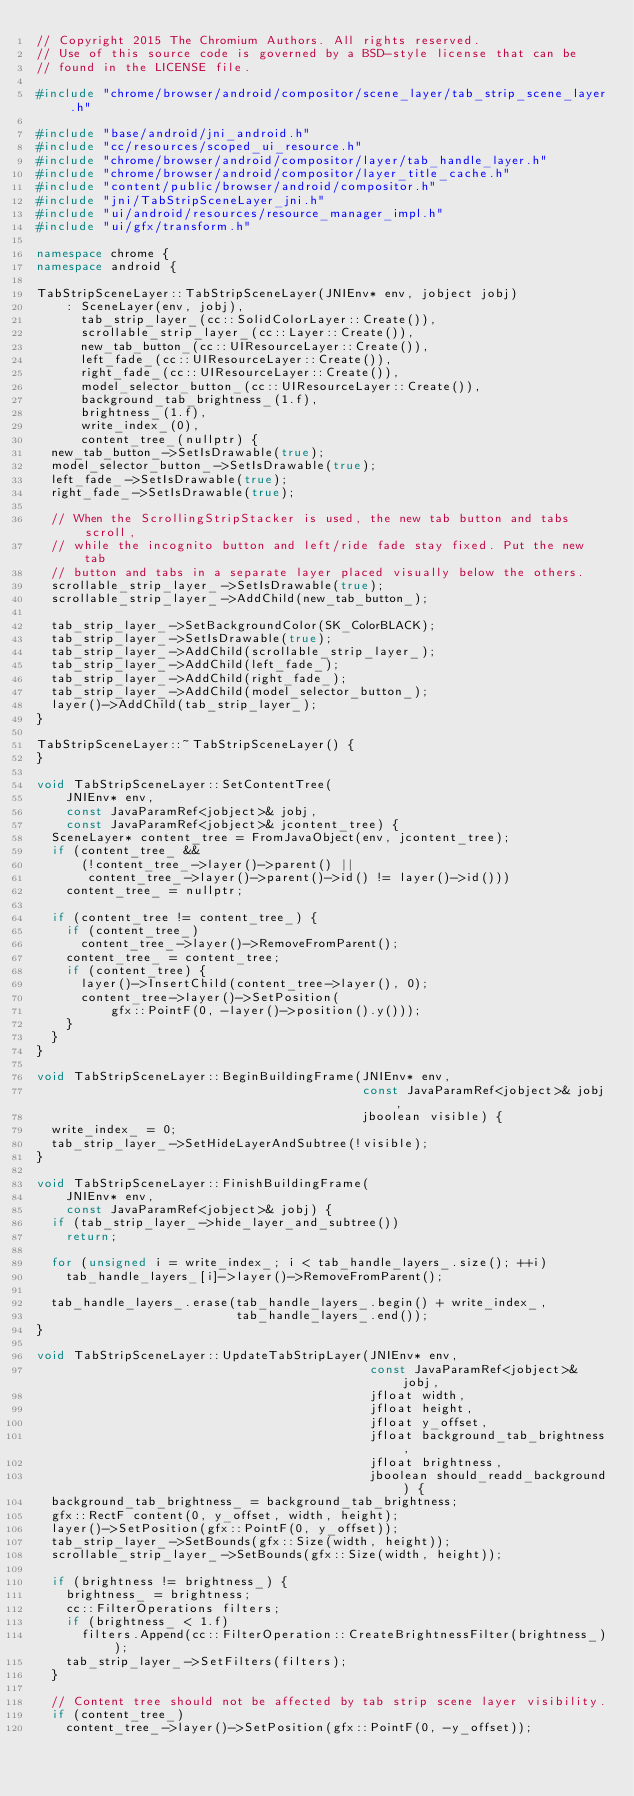<code> <loc_0><loc_0><loc_500><loc_500><_C++_>// Copyright 2015 The Chromium Authors. All rights reserved.
// Use of this source code is governed by a BSD-style license that can be
// found in the LICENSE file.

#include "chrome/browser/android/compositor/scene_layer/tab_strip_scene_layer.h"

#include "base/android/jni_android.h"
#include "cc/resources/scoped_ui_resource.h"
#include "chrome/browser/android/compositor/layer/tab_handle_layer.h"
#include "chrome/browser/android/compositor/layer_title_cache.h"
#include "content/public/browser/android/compositor.h"
#include "jni/TabStripSceneLayer_jni.h"
#include "ui/android/resources/resource_manager_impl.h"
#include "ui/gfx/transform.h"

namespace chrome {
namespace android {

TabStripSceneLayer::TabStripSceneLayer(JNIEnv* env, jobject jobj)
    : SceneLayer(env, jobj),
      tab_strip_layer_(cc::SolidColorLayer::Create()),
      scrollable_strip_layer_(cc::Layer::Create()),
      new_tab_button_(cc::UIResourceLayer::Create()),
      left_fade_(cc::UIResourceLayer::Create()),
      right_fade_(cc::UIResourceLayer::Create()),
      model_selector_button_(cc::UIResourceLayer::Create()),
      background_tab_brightness_(1.f),
      brightness_(1.f),
      write_index_(0),
      content_tree_(nullptr) {
  new_tab_button_->SetIsDrawable(true);
  model_selector_button_->SetIsDrawable(true);
  left_fade_->SetIsDrawable(true);
  right_fade_->SetIsDrawable(true);

  // When the ScrollingStripStacker is used, the new tab button and tabs scroll,
  // while the incognito button and left/ride fade stay fixed. Put the new tab
  // button and tabs in a separate layer placed visually below the others.
  scrollable_strip_layer_->SetIsDrawable(true);
  scrollable_strip_layer_->AddChild(new_tab_button_);

  tab_strip_layer_->SetBackgroundColor(SK_ColorBLACK);
  tab_strip_layer_->SetIsDrawable(true);
  tab_strip_layer_->AddChild(scrollable_strip_layer_);
  tab_strip_layer_->AddChild(left_fade_);
  tab_strip_layer_->AddChild(right_fade_);
  tab_strip_layer_->AddChild(model_selector_button_);
  layer()->AddChild(tab_strip_layer_);
}

TabStripSceneLayer::~TabStripSceneLayer() {
}

void TabStripSceneLayer::SetContentTree(
    JNIEnv* env,
    const JavaParamRef<jobject>& jobj,
    const JavaParamRef<jobject>& jcontent_tree) {
  SceneLayer* content_tree = FromJavaObject(env, jcontent_tree);
  if (content_tree_ &&
      (!content_tree_->layer()->parent() ||
       content_tree_->layer()->parent()->id() != layer()->id()))
    content_tree_ = nullptr;

  if (content_tree != content_tree_) {
    if (content_tree_)
      content_tree_->layer()->RemoveFromParent();
    content_tree_ = content_tree;
    if (content_tree) {
      layer()->InsertChild(content_tree->layer(), 0);
      content_tree->layer()->SetPosition(
          gfx::PointF(0, -layer()->position().y()));
    }
  }
}

void TabStripSceneLayer::BeginBuildingFrame(JNIEnv* env,
                                            const JavaParamRef<jobject>& jobj,
                                            jboolean visible) {
  write_index_ = 0;
  tab_strip_layer_->SetHideLayerAndSubtree(!visible);
}

void TabStripSceneLayer::FinishBuildingFrame(
    JNIEnv* env,
    const JavaParamRef<jobject>& jobj) {
  if (tab_strip_layer_->hide_layer_and_subtree())
    return;

  for (unsigned i = write_index_; i < tab_handle_layers_.size(); ++i)
    tab_handle_layers_[i]->layer()->RemoveFromParent();

  tab_handle_layers_.erase(tab_handle_layers_.begin() + write_index_,
                           tab_handle_layers_.end());
}

void TabStripSceneLayer::UpdateTabStripLayer(JNIEnv* env,
                                             const JavaParamRef<jobject>& jobj,
                                             jfloat width,
                                             jfloat height,
                                             jfloat y_offset,
                                             jfloat background_tab_brightness,
                                             jfloat brightness,
                                             jboolean should_readd_background) {
  background_tab_brightness_ = background_tab_brightness;
  gfx::RectF content(0, y_offset, width, height);
  layer()->SetPosition(gfx::PointF(0, y_offset));
  tab_strip_layer_->SetBounds(gfx::Size(width, height));
  scrollable_strip_layer_->SetBounds(gfx::Size(width, height));

  if (brightness != brightness_) {
    brightness_ = brightness;
    cc::FilterOperations filters;
    if (brightness_ < 1.f)
      filters.Append(cc::FilterOperation::CreateBrightnessFilter(brightness_));
    tab_strip_layer_->SetFilters(filters);
  }

  // Content tree should not be affected by tab strip scene layer visibility.
  if (content_tree_)
    content_tree_->layer()->SetPosition(gfx::PointF(0, -y_offset));
</code> 